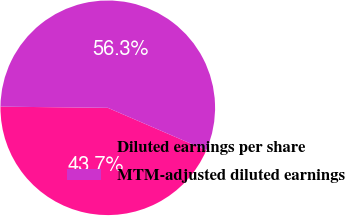Convert chart. <chart><loc_0><loc_0><loc_500><loc_500><pie_chart><fcel>Diluted earnings per share<fcel>MTM-adjusted diluted earnings<nl><fcel>43.69%<fcel>56.31%<nl></chart> 